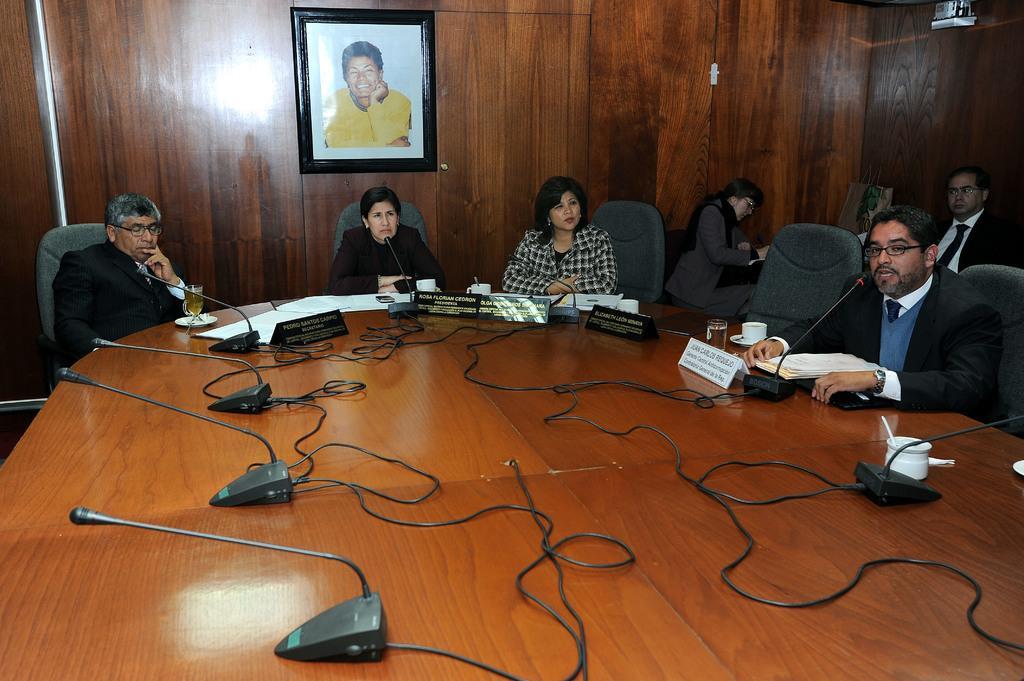Describe this image in one or two sentences. On a wooden table there are microphones, glass, cups, name plates and papers. People are sitting on the chairs. There is a photo frame at the back. 